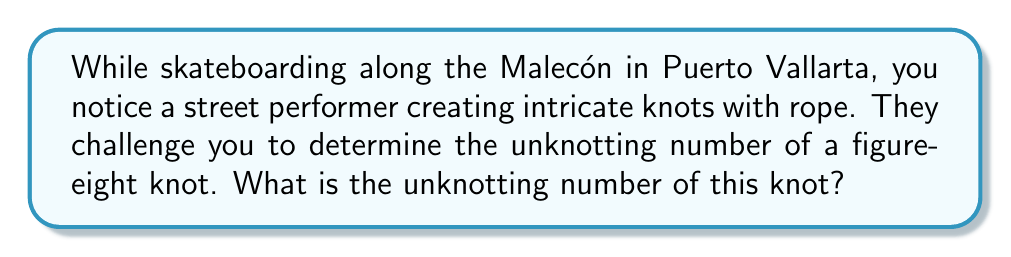Show me your answer to this math problem. To determine the unknotting number of a figure-eight knot, we need to follow these steps:

1. Understand the definition: The unknotting number is the minimum number of crossing changes required to transform a knot into the unknot (trivial knot).

2. Examine the figure-eight knot:
   The figure-eight knot, also known as the 4₁ knot, has four crossings in its standard diagram.

   [asy]
   import geometry;

   pair A = (0,0), B = (1,1), C = (2,0), D = (1,-1);
   pair E = (0.5,0.5), F = (1.5,0.5);

   draw(A..E..B..F..C..D--cycle);
   draw(B..E..A..F..C..D--cycle);

   dot("A", A, SW);
   dot("B", B, NE);
   dot("C", C, SE);
   dot("D", D, SW);
   [/asy]

3. Consider possible unknotting operations:
   - Changing any single crossing will not unknot the figure-eight knot.
   - We need to change at least two crossings to unknot it.

4. Prove the lower bound:
   - The figure-eight knot has a non-zero signature, which means its unknotting number is at least 1.
   - It's not possible to unknot it with just one crossing change, so the unknotting number must be at least 2.

5. Demonstrate an unknotting sequence:
   - Change two opposite crossings in the standard diagram.
   - This transforms the figure-eight knot into the unknot.

6. Conclusion:
   Since we've proven a lower bound of 2 and demonstrated an unknotting sequence with 2 crossing changes, the unknotting number of the figure-eight knot is exactly 2.
Answer: 2 